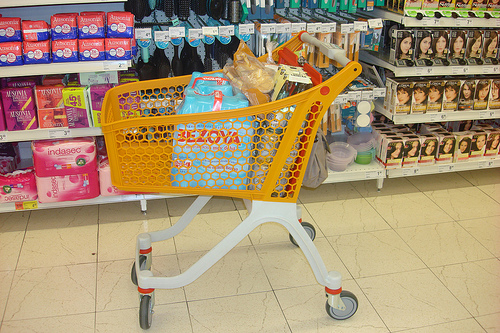<image>
Can you confirm if the hair dye is on the cart? No. The hair dye is not positioned on the cart. They may be near each other, but the hair dye is not supported by or resting on top of the cart. Is there a package in front of the shopping cart? No. The package is not in front of the shopping cart. The spatial positioning shows a different relationship between these objects. 